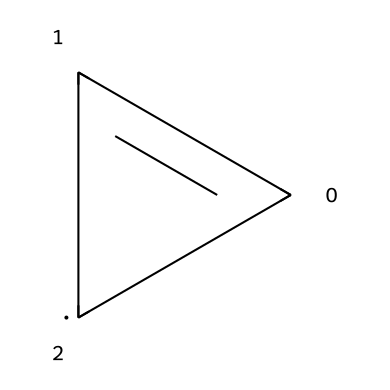What is the total number of carbon atoms in this structure? The SMILES representation indicates that there are two carbon atoms in a cyclic structure, represented by "C1=C" and "[C@H]1."
Answer: two How many double bonds are present in this chemical? The structure contains one double bond, denoted by "C=C" in the SMILES representation.
Answer: one What type of isomerism is represented by this cyclic carbene? The molecule shows geometric isomerism due to the presence of a double bond and two different substituents around that bond.
Answer: geometric isomerism How does the stereochemistry affect the reactivity of this cyclic carbene? The specific arrangement of substituents (cis or trans) influences steric hindrance and the approach of reactants, affecting its reactivity in reactions.
Answer: influences reactivity What is the hybridization of the carbon atoms in this cyclic carbene structure? The carbon atoms involved in the double bond are sp2 hybridized, a result of the double bond formation and the connection to other atoms.
Answer: sp2 